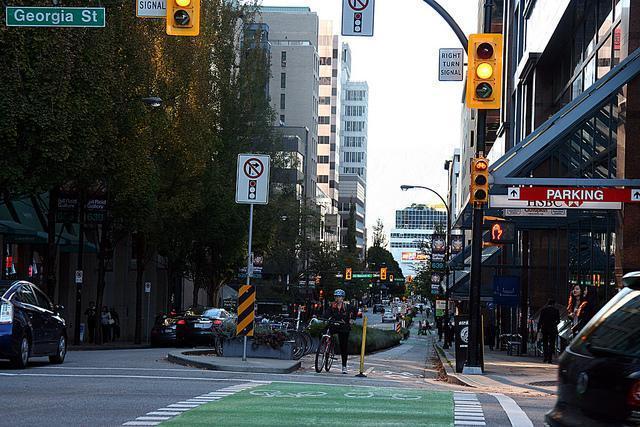How many cyclist are present?
Give a very brief answer. 1. How many cars can you see?
Give a very brief answer. 2. 